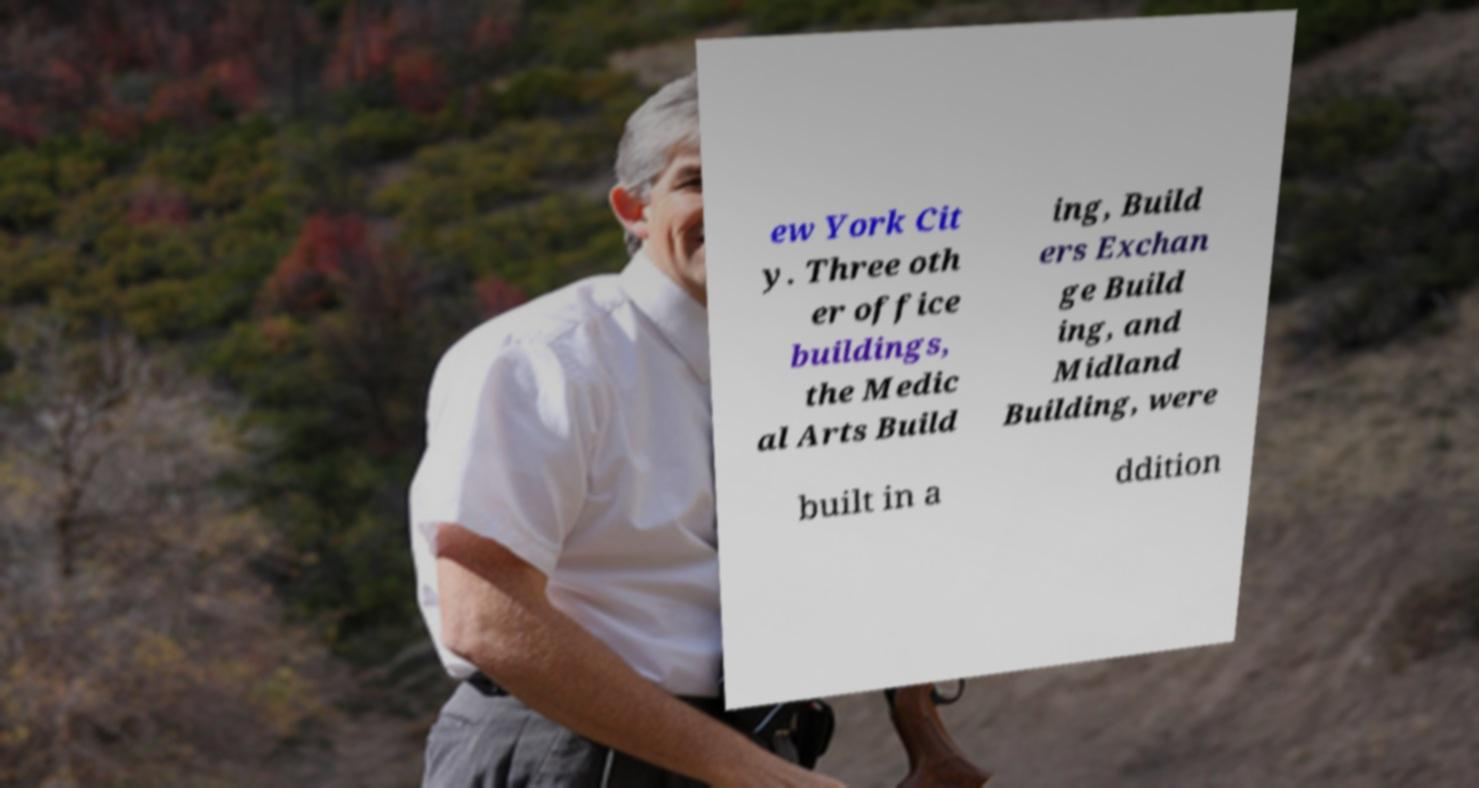I need the written content from this picture converted into text. Can you do that? ew York Cit y. Three oth er office buildings, the Medic al Arts Build ing, Build ers Exchan ge Build ing, and Midland Building, were built in a ddition 